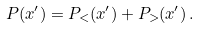Convert formula to latex. <formula><loc_0><loc_0><loc_500><loc_500>P ( x ^ { \prime } ) = P _ { < } ( x ^ { \prime } ) + P _ { > } ( x ^ { \prime } ) \, .</formula> 